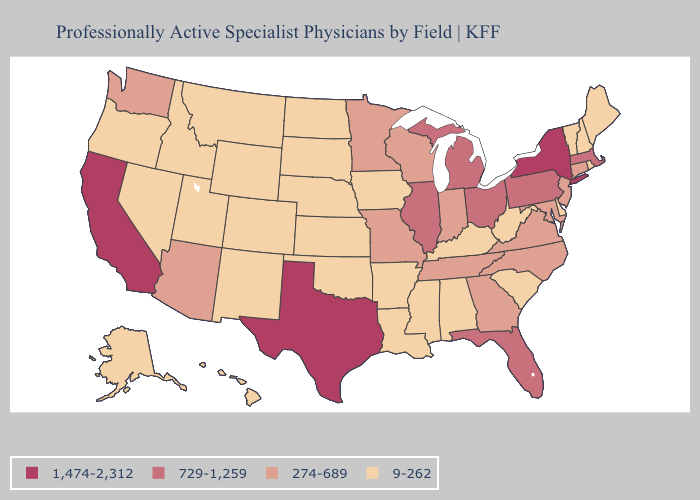How many symbols are there in the legend?
Concise answer only. 4. Does West Virginia have the highest value in the USA?
Keep it brief. No. Among the states that border Kentucky , does Indiana have the highest value?
Give a very brief answer. No. What is the value of Colorado?
Answer briefly. 9-262. What is the lowest value in states that border Nebraska?
Give a very brief answer. 9-262. Is the legend a continuous bar?
Answer briefly. No. Does the map have missing data?
Write a very short answer. No. Name the states that have a value in the range 1,474-2,312?
Be succinct. California, New York, Texas. Name the states that have a value in the range 274-689?
Write a very short answer. Arizona, Connecticut, Georgia, Indiana, Maryland, Minnesota, Missouri, New Jersey, North Carolina, Tennessee, Virginia, Washington, Wisconsin. What is the value of New York?
Keep it brief. 1,474-2,312. Does Tennessee have the lowest value in the South?
Concise answer only. No. Name the states that have a value in the range 1,474-2,312?
Short answer required. California, New York, Texas. Does Florida have the lowest value in the USA?
Be succinct. No. Name the states that have a value in the range 9-262?
Answer briefly. Alabama, Alaska, Arkansas, Colorado, Delaware, Hawaii, Idaho, Iowa, Kansas, Kentucky, Louisiana, Maine, Mississippi, Montana, Nebraska, Nevada, New Hampshire, New Mexico, North Dakota, Oklahoma, Oregon, Rhode Island, South Carolina, South Dakota, Utah, Vermont, West Virginia, Wyoming. 